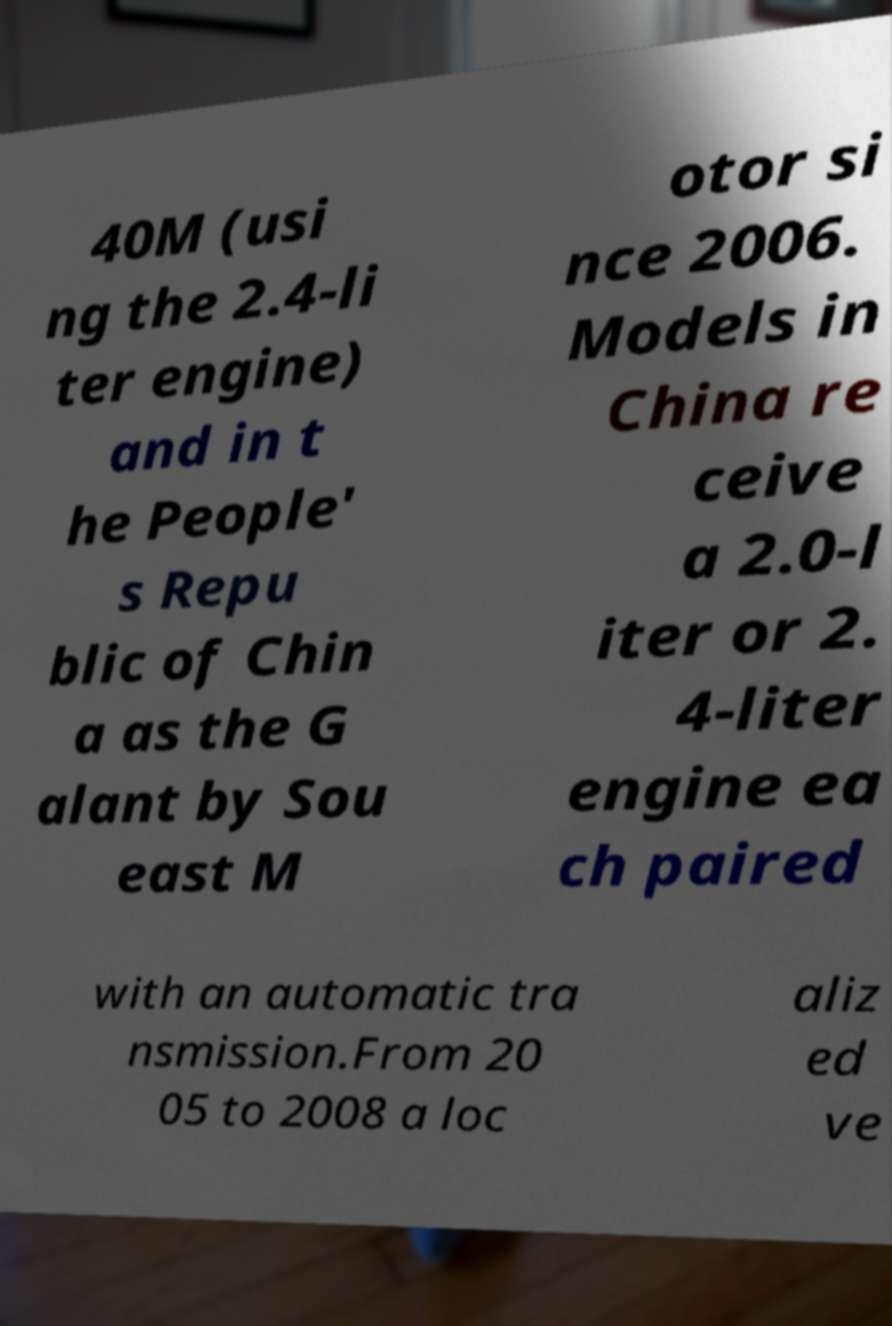Could you extract and type out the text from this image? 40M (usi ng the 2.4-li ter engine) and in t he People' s Repu blic of Chin a as the G alant by Sou east M otor si nce 2006. Models in China re ceive a 2.0-l iter or 2. 4-liter engine ea ch paired with an automatic tra nsmission.From 20 05 to 2008 a loc aliz ed ve 